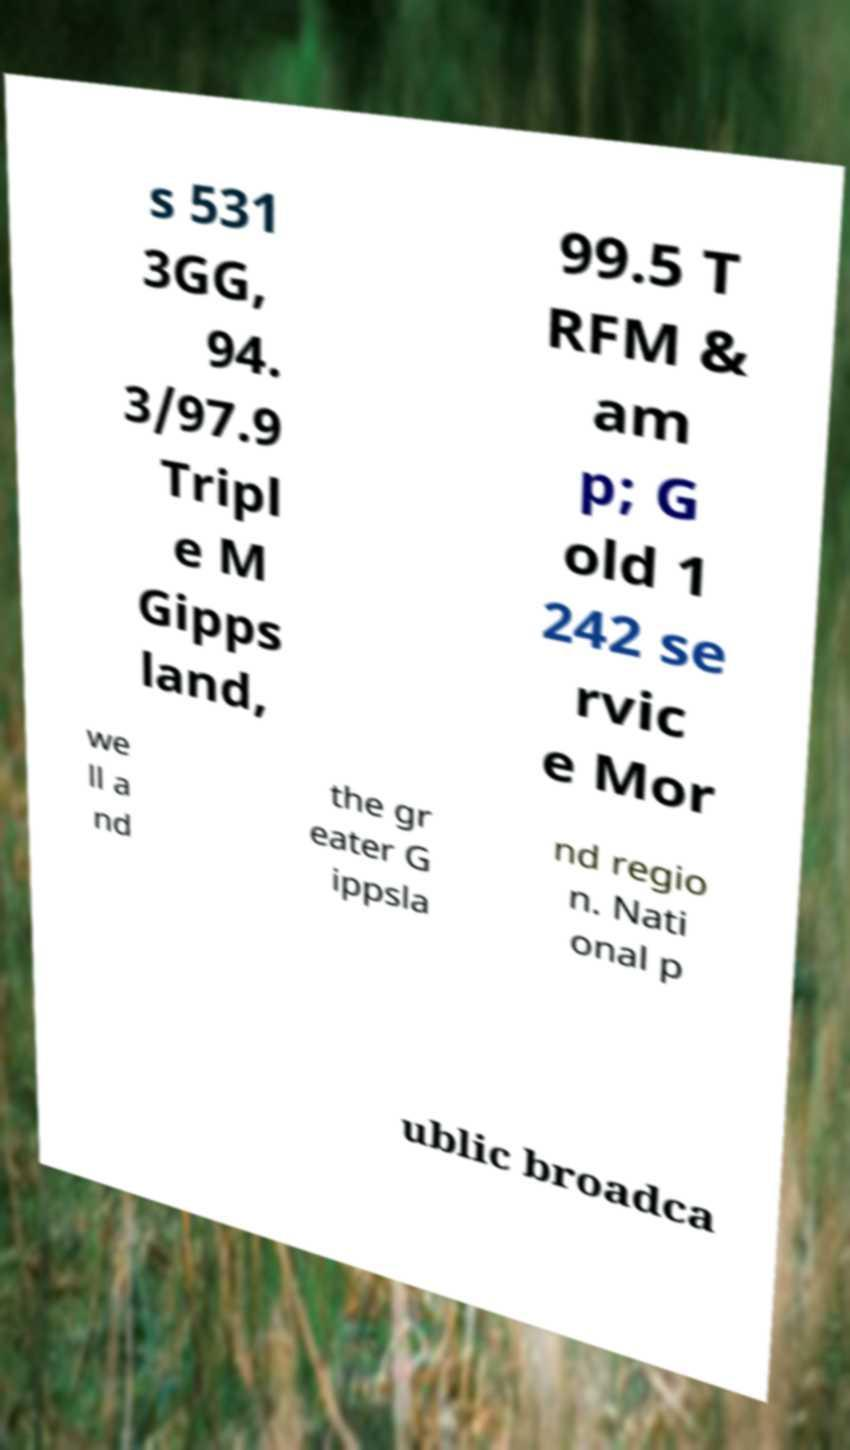Can you read and provide the text displayed in the image?This photo seems to have some interesting text. Can you extract and type it out for me? s 531 3GG, 94. 3/97.9 Tripl e M Gipps land, 99.5 T RFM & am p; G old 1 242 se rvic e Mor we ll a nd the gr eater G ippsla nd regio n. Nati onal p ublic broadca 